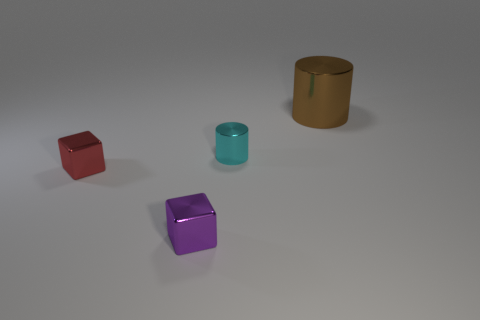Is the number of objects that are on the right side of the tiny cyan cylinder greater than the number of brown objects on the left side of the red shiny object?
Keep it short and to the point. Yes. What number of objects are small purple shiny objects or small red metallic blocks?
Give a very brief answer. 2. There is a block that is in front of the red metal cube; does it have the same size as the small metallic cylinder?
Provide a short and direct response. Yes. How many other objects are the same size as the purple metal block?
Offer a terse response. 2. Is there a tiny thing?
Offer a terse response. Yes. What is the size of the metallic thing to the left of the tiny block that is on the right side of the small red block?
Provide a short and direct response. Small. What color is the small metallic object that is both to the right of the tiny red metal object and left of the cyan shiny object?
Offer a very short reply. Purple. What number of other objects are the same shape as the large object?
Offer a very short reply. 1. There is another metallic cube that is the same size as the red metallic block; what is its color?
Give a very brief answer. Purple. The cylinder that is to the left of the big cylinder is what color?
Give a very brief answer. Cyan. 